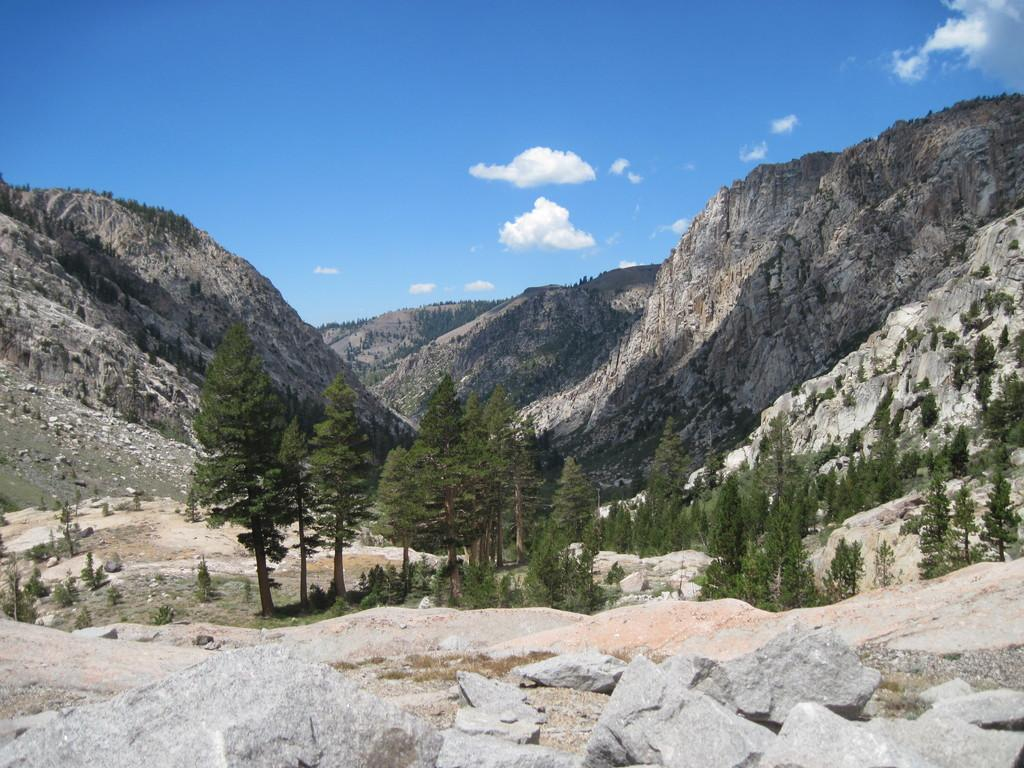What is on the ground in the image? There are stones on the ground. What can be seen in the background of the image? There are trees, mountains, and clouds in the sky in the background of the image. What type of club can be seen in the image? There is no club present in the image. What color is the orange in the image? There is no orange present in the image. 